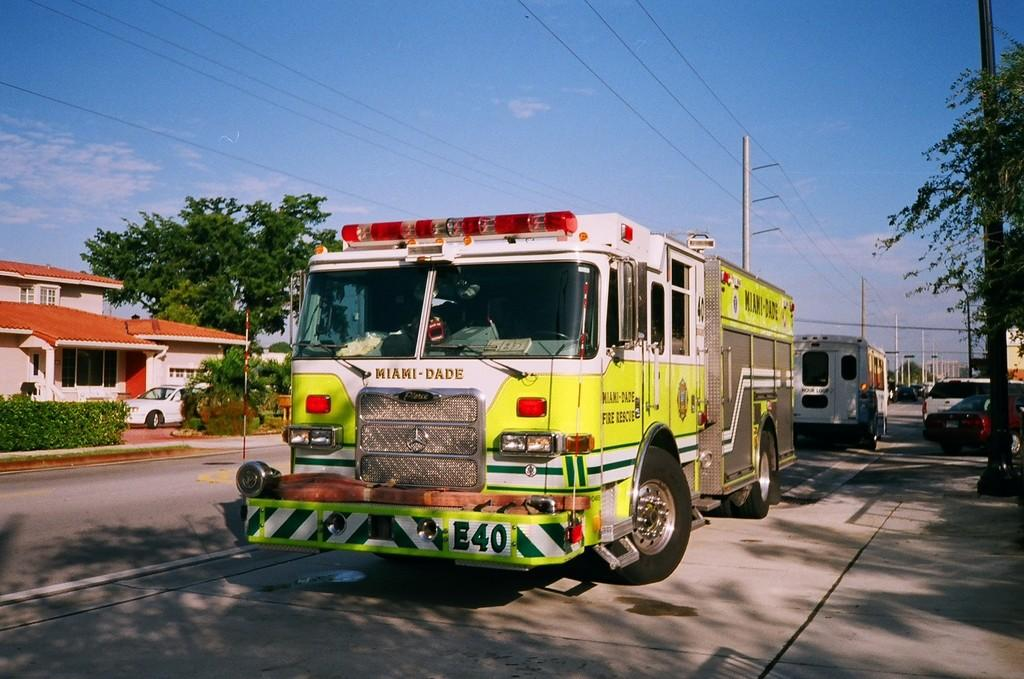What can be seen on the road in the image? There are vehicles on the road. What is visible in the background of the image? There are trees, vehicles, buildings, windows, electric poles, and wires in the background. What is the condition of the sky in the image? There are clouds in the sky. Where is the bed located in the image? There is no bed present in the image. What type of shade is provided by the trees in the image? There is no mention of shade in the image, as it focuses on the vehicles and background elements. 